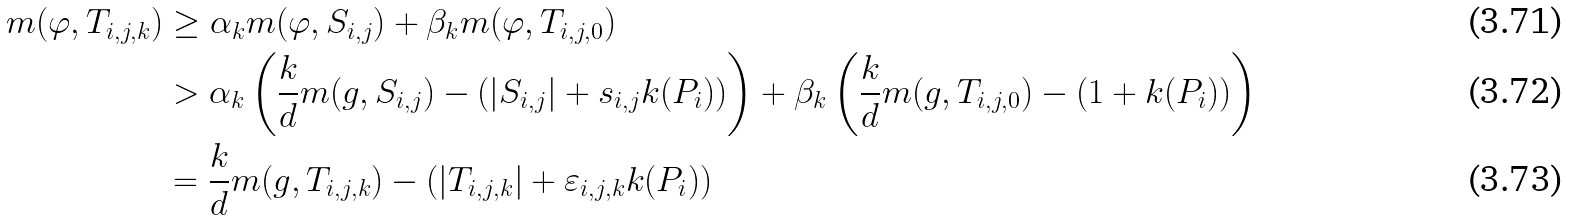<formula> <loc_0><loc_0><loc_500><loc_500>m ( \varphi , T _ { i , j , k } ) & \geq \alpha _ { k } m ( \varphi , S _ { i , j } ) + \beta _ { k } m ( \varphi , T _ { i , j , 0 } ) \\ & > \alpha _ { k } \left ( \frac { k } { d } m ( g , S _ { i , j } ) - ( | S _ { i , j } | + s _ { i , j } k ( P _ { i } ) ) \right ) + \beta _ { k } \left ( \frac { k } { d } m ( g , T _ { i , j , 0 } ) - ( 1 + k ( P _ { i } ) ) \right ) \\ & = \frac { k } { d } m ( g , T _ { i , j , k } ) - ( | T _ { i , j , k } | + \varepsilon _ { i , j , k } k ( P _ { i } ) )</formula> 